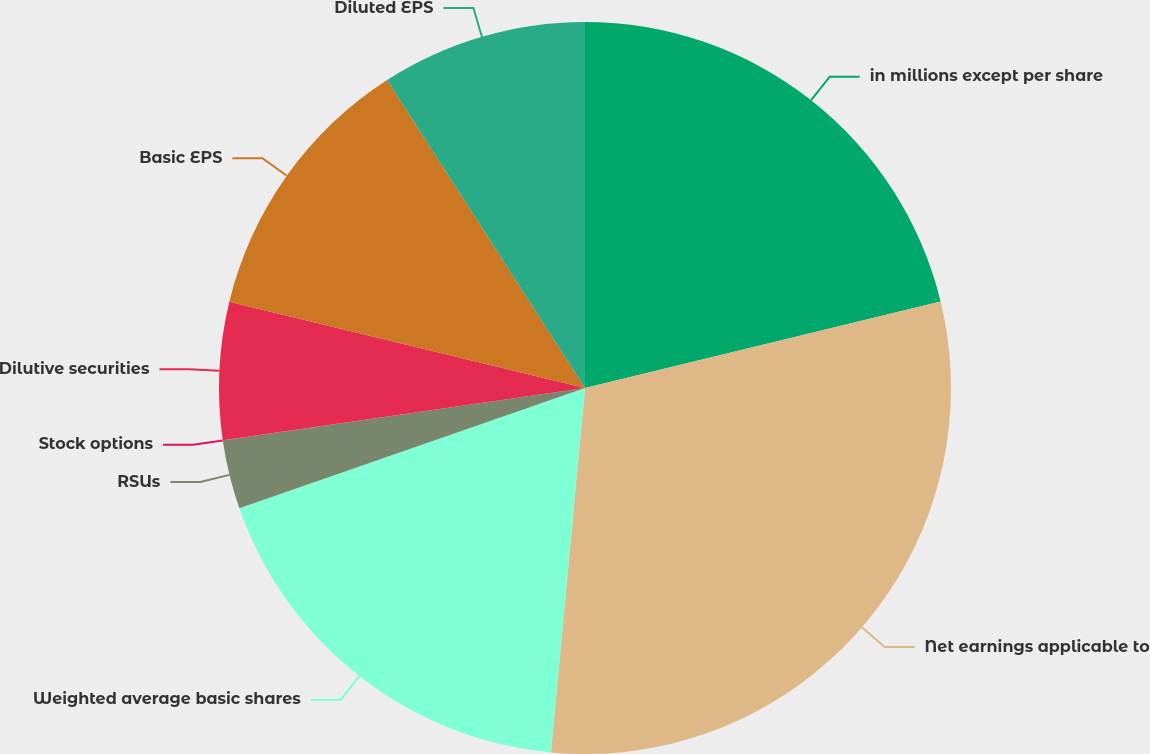Convert chart. <chart><loc_0><loc_0><loc_500><loc_500><pie_chart><fcel>in millions except per share<fcel>Net earnings applicable to<fcel>Weighted average basic shares<fcel>RSUs<fcel>Stock options<fcel>Dilutive securities<fcel>Basic EPS<fcel>Diluted EPS<nl><fcel>21.2%<fcel>30.28%<fcel>18.18%<fcel>3.04%<fcel>0.01%<fcel>6.07%<fcel>12.12%<fcel>9.09%<nl></chart> 